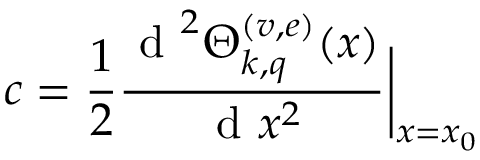Convert formula to latex. <formula><loc_0><loc_0><loc_500><loc_500>c = \frac { 1 } { 2 } \frac { d ^ { 2 } \Theta _ { k , q } ^ { ( v , e ) } ( x ) } { d x ^ { 2 } } \Big | _ { x = x _ { 0 } }</formula> 